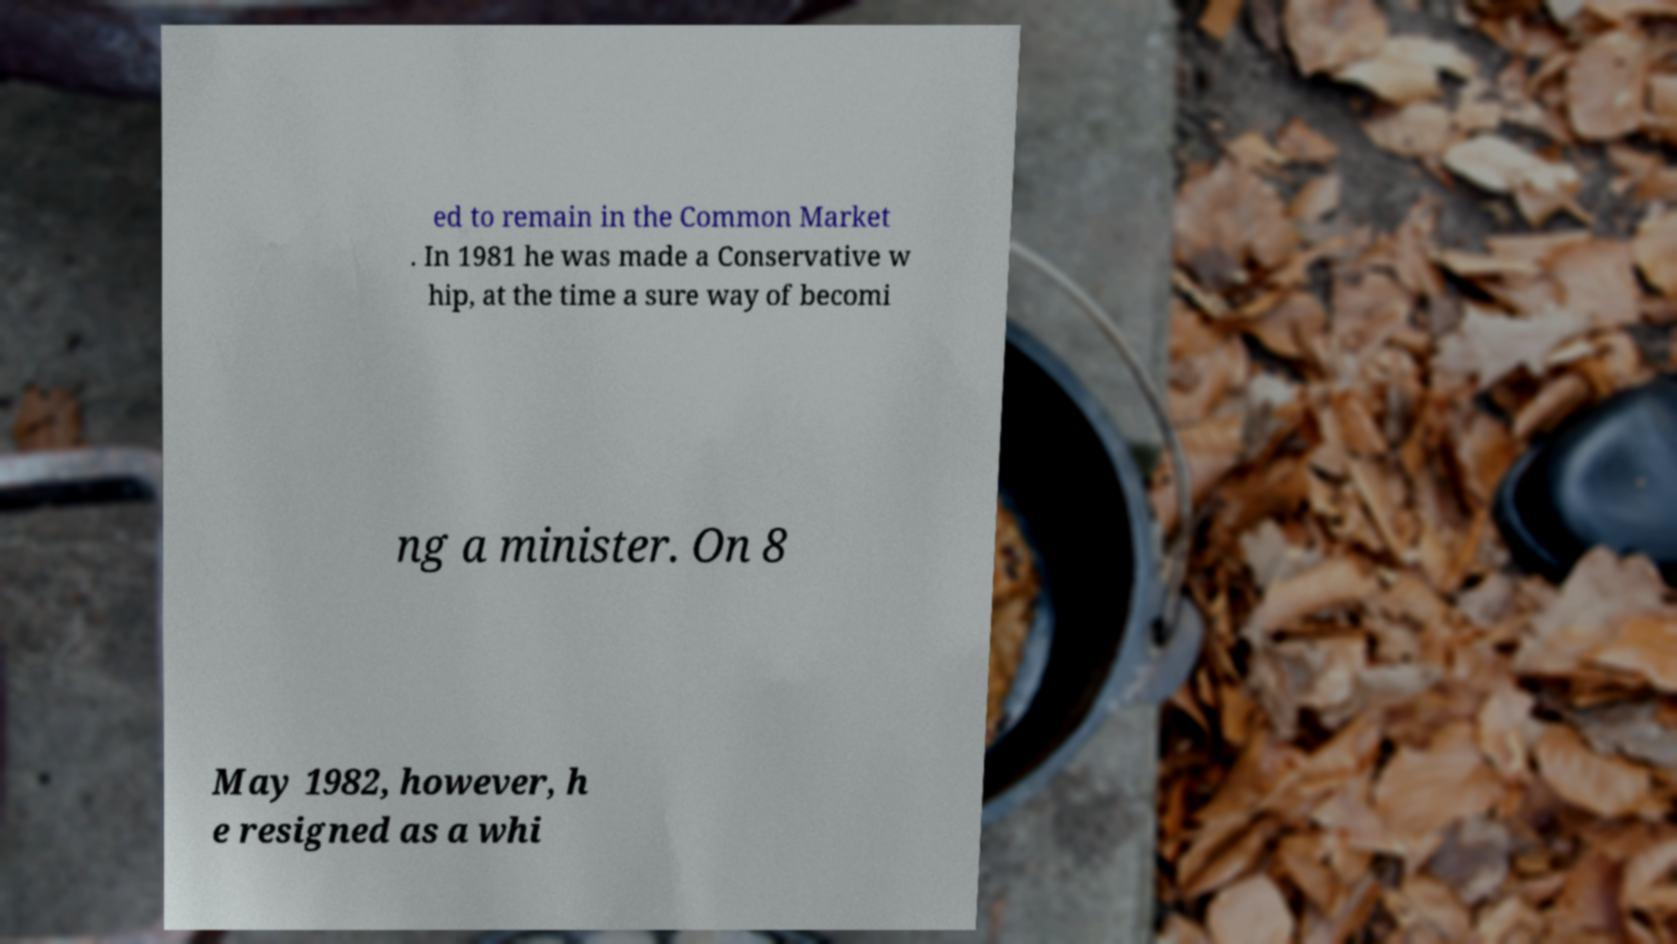For documentation purposes, I need the text within this image transcribed. Could you provide that? ed to remain in the Common Market . In 1981 he was made a Conservative w hip, at the time a sure way of becomi ng a minister. On 8 May 1982, however, h e resigned as a whi 